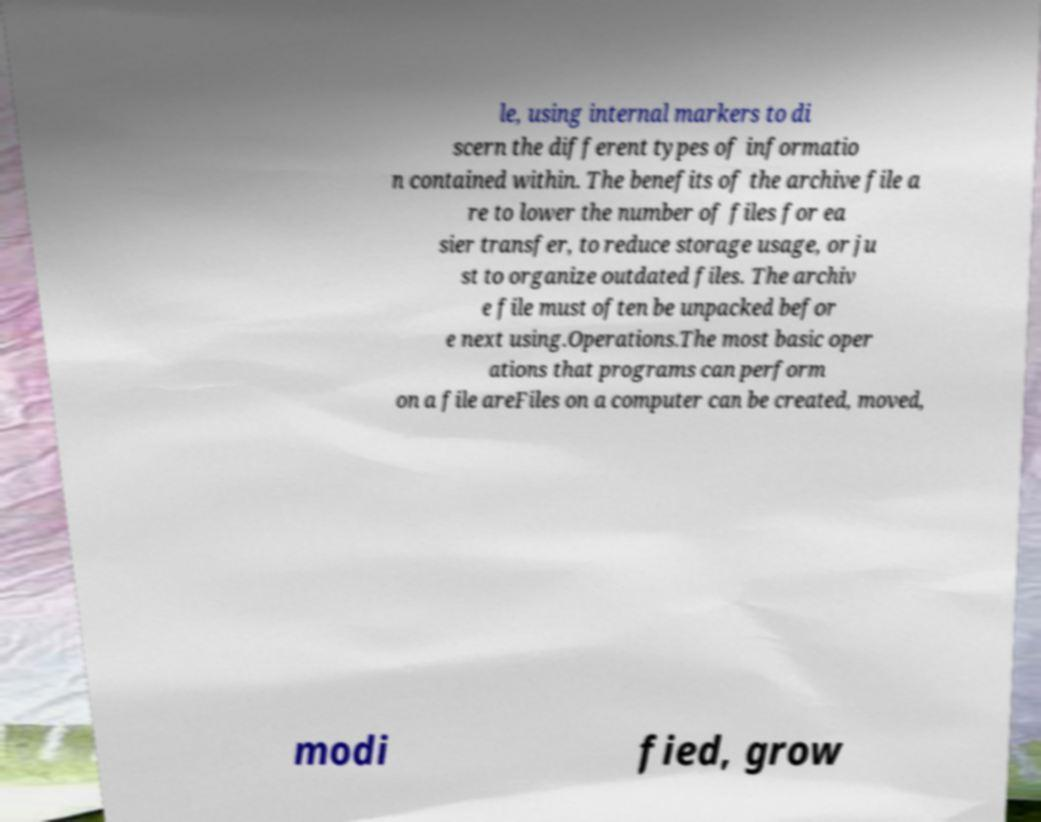Please identify and transcribe the text found in this image. le, using internal markers to di scern the different types of informatio n contained within. The benefits of the archive file a re to lower the number of files for ea sier transfer, to reduce storage usage, or ju st to organize outdated files. The archiv e file must often be unpacked befor e next using.Operations.The most basic oper ations that programs can perform on a file areFiles on a computer can be created, moved, modi fied, grow 